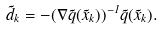Convert formula to latex. <formula><loc_0><loc_0><loc_500><loc_500>\vec { d } _ { k } = - ( \nabla \vec { q } ( \vec { x } _ { k } ) ) ^ { - 1 } \vec { q } ( \vec { x } _ { k } ) .</formula> 